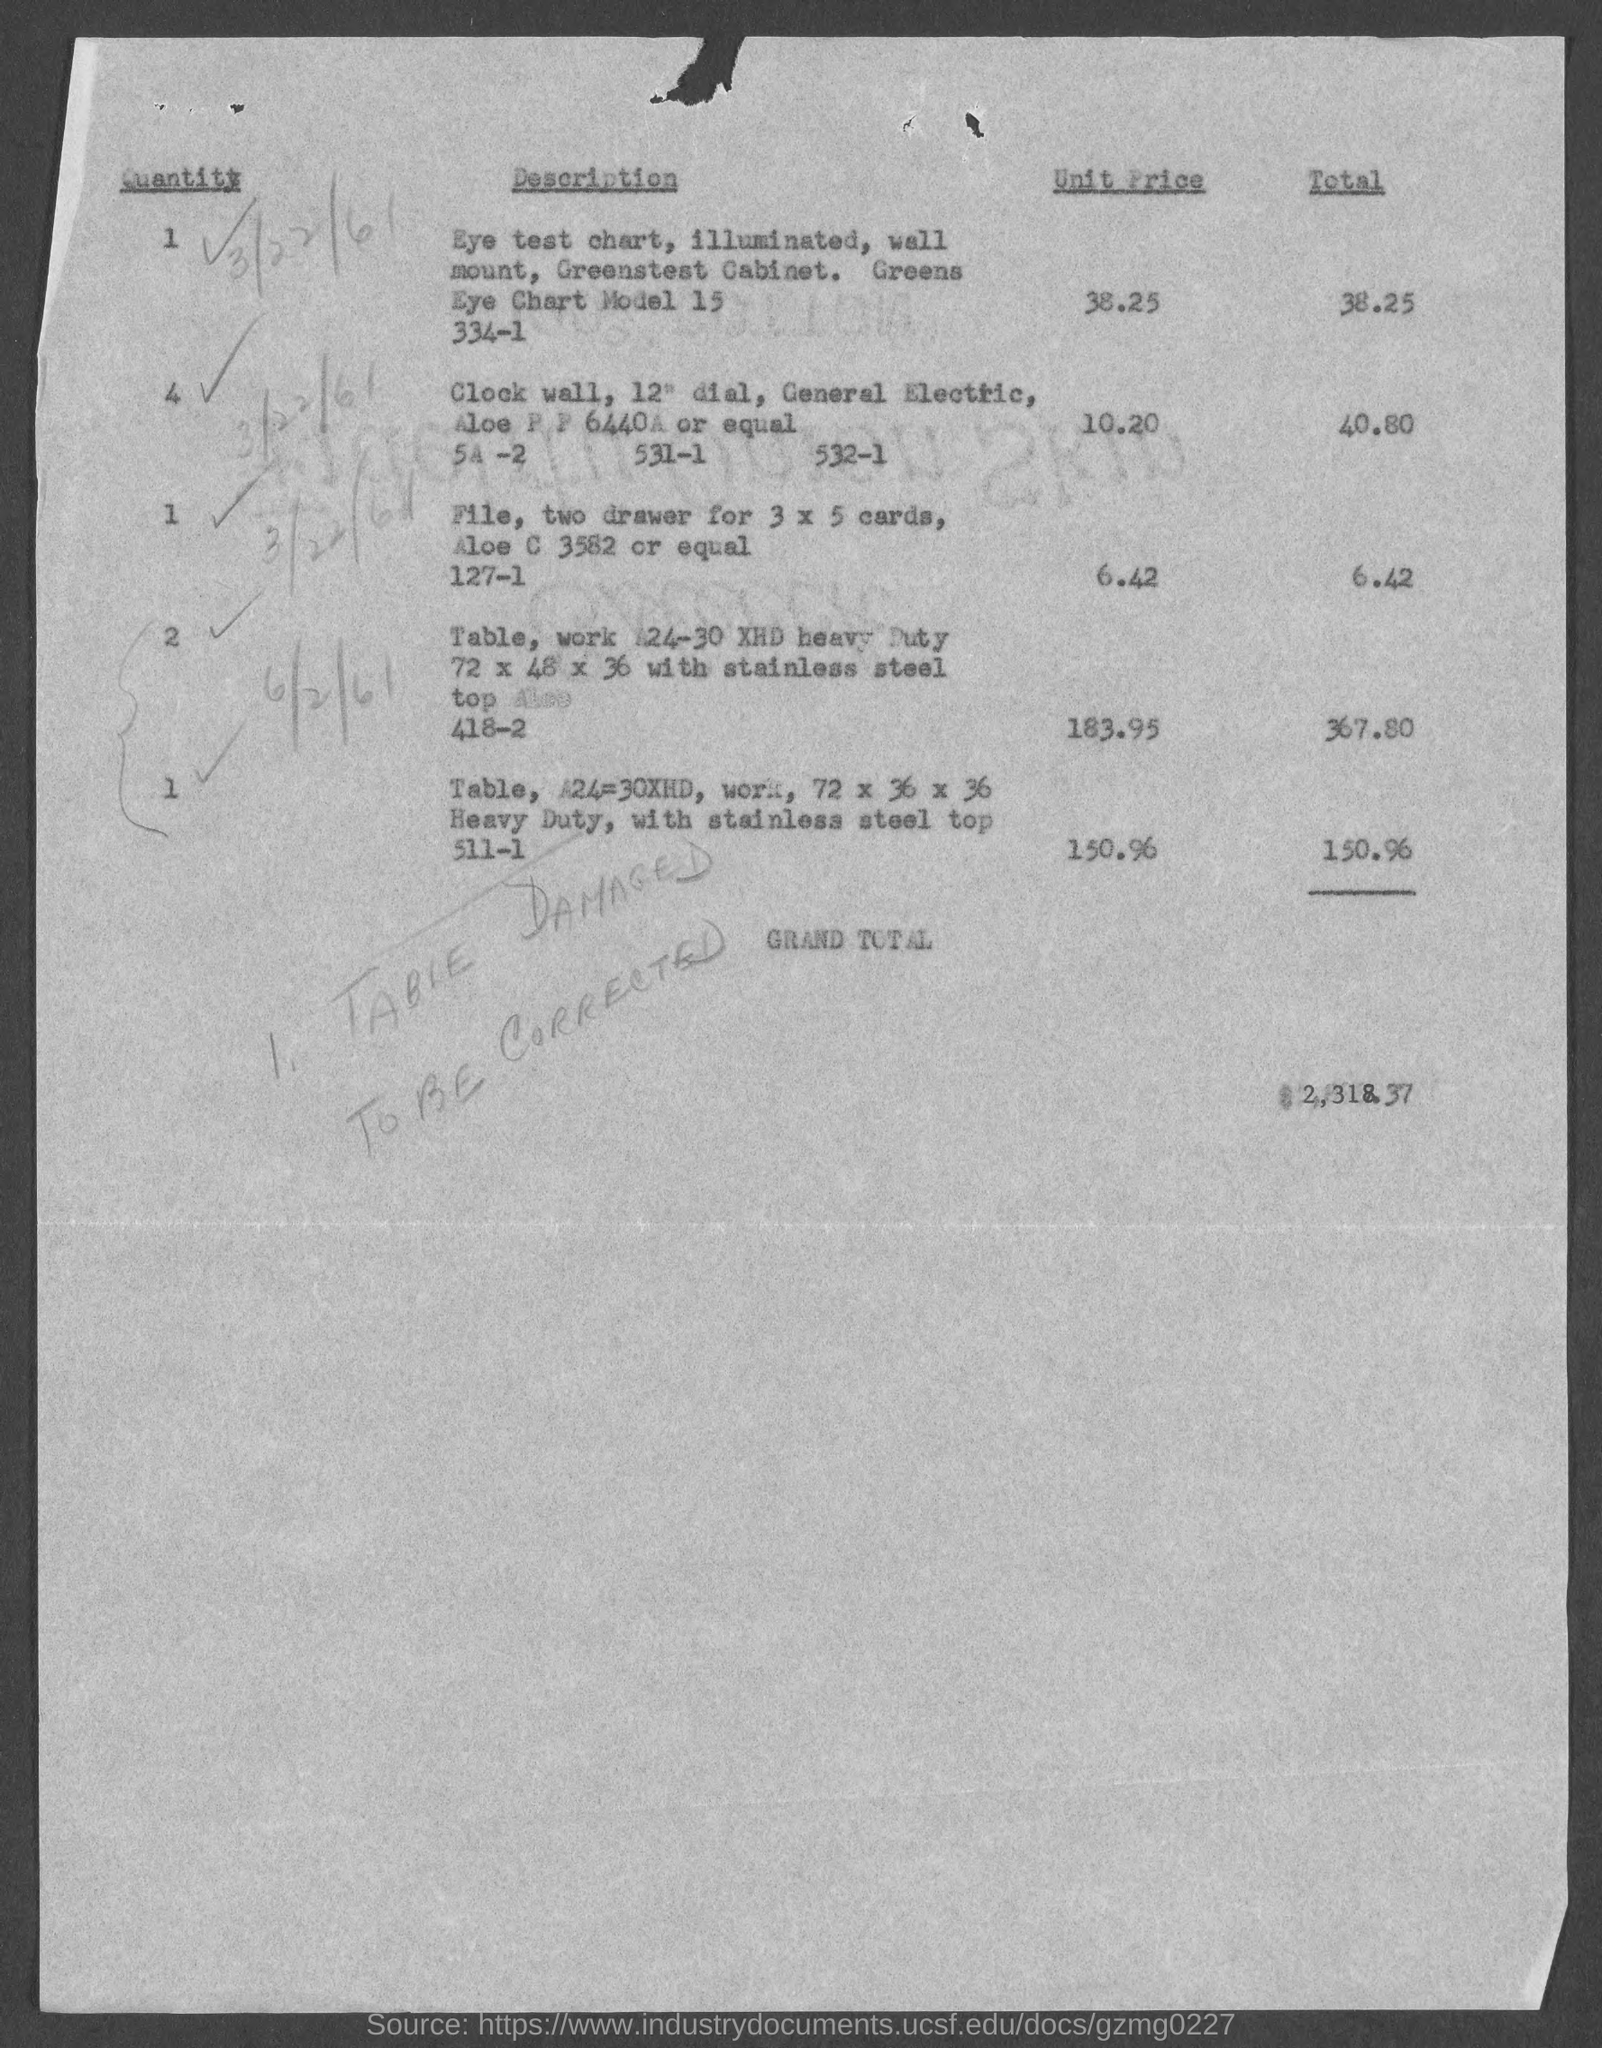What is the Unit Price of the item 'Eye test chart' mentioned in 'Description'?
Your answer should be compact. 38.25. What is the quantity of the item 'Clock wall' mentioned in 'Description'?
Your answer should be compact. 4. What is the 'Total' value of the item 'Clock wall' mentioned in 'Description' ?
Offer a very short reply. 40.80. 